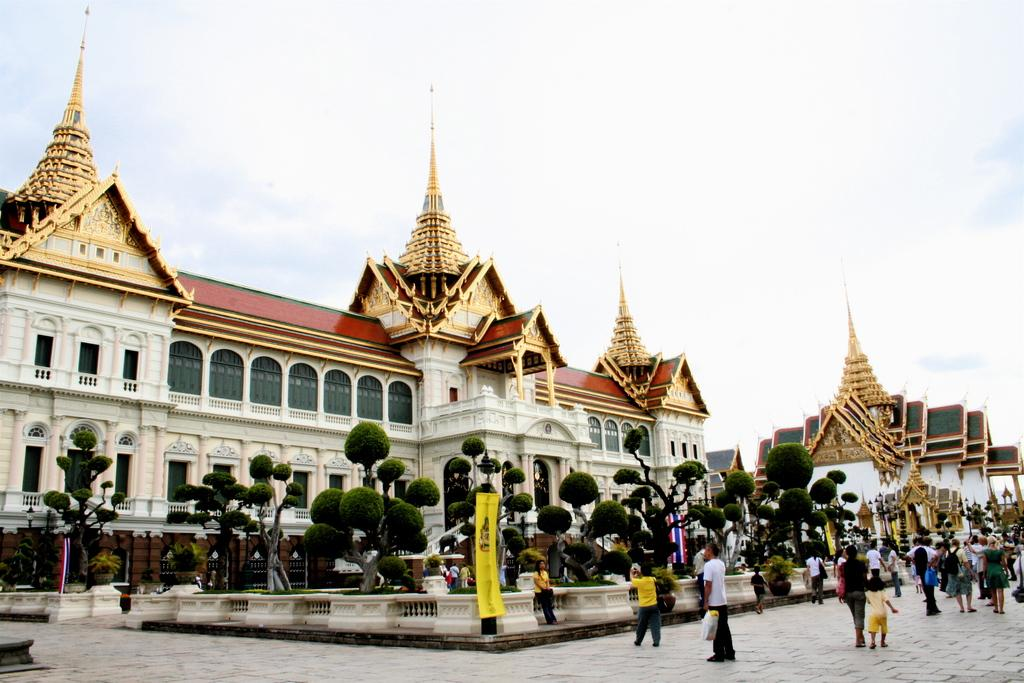What type of structures can be seen in the image? There are buildings in the image. What other natural elements are present in the image? There are trees in the image. Are there any people visible in the image? Yes, there are people standing in the image. What decorative elements can be seen hanging in the image? There are banners hanging in the image. How would you describe the weather based on the image? The sky is cloudy in the image, suggesting a potentially overcast or cloudy day. What type of leather is being used to make the crib in the image? There is no crib present in the image, so it is not possible to determine the type of leather being used. 